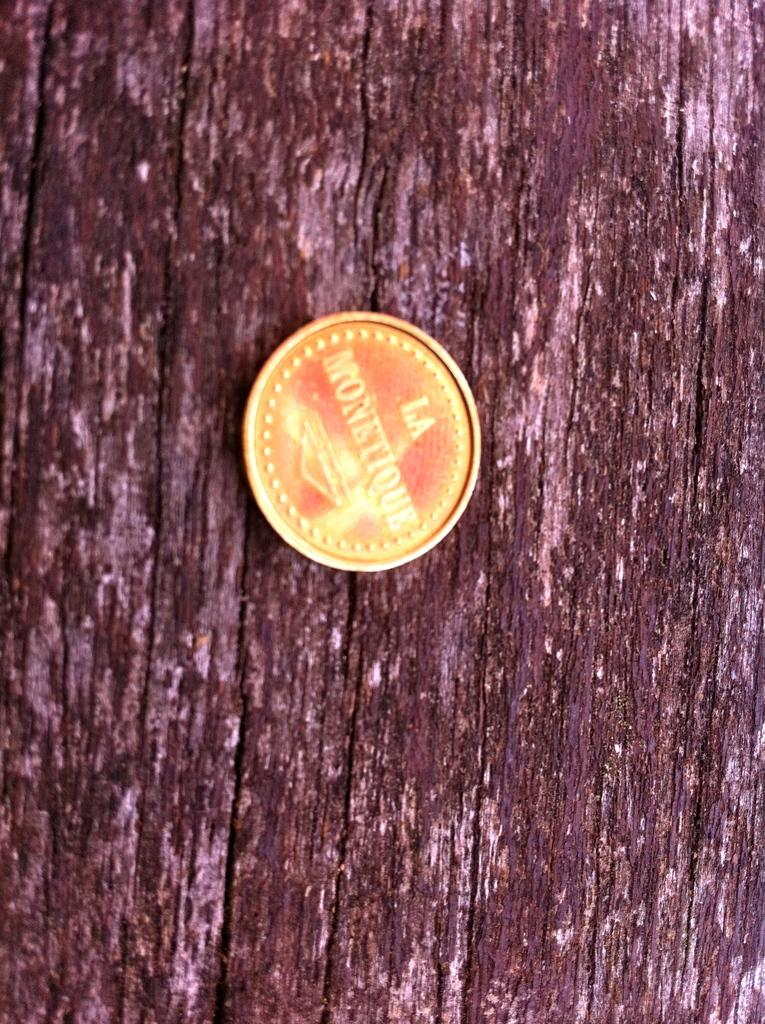What object is the main focus of the image? The main object in the image is a coin. Can you describe the surface on which the coin is placed? The coin is on a wooden surface. Is there a bike visible in the image? No, there is no bike present in the image. Can you see any feet or shoes in the image? No, there are no feet or shoes visible in the image. 